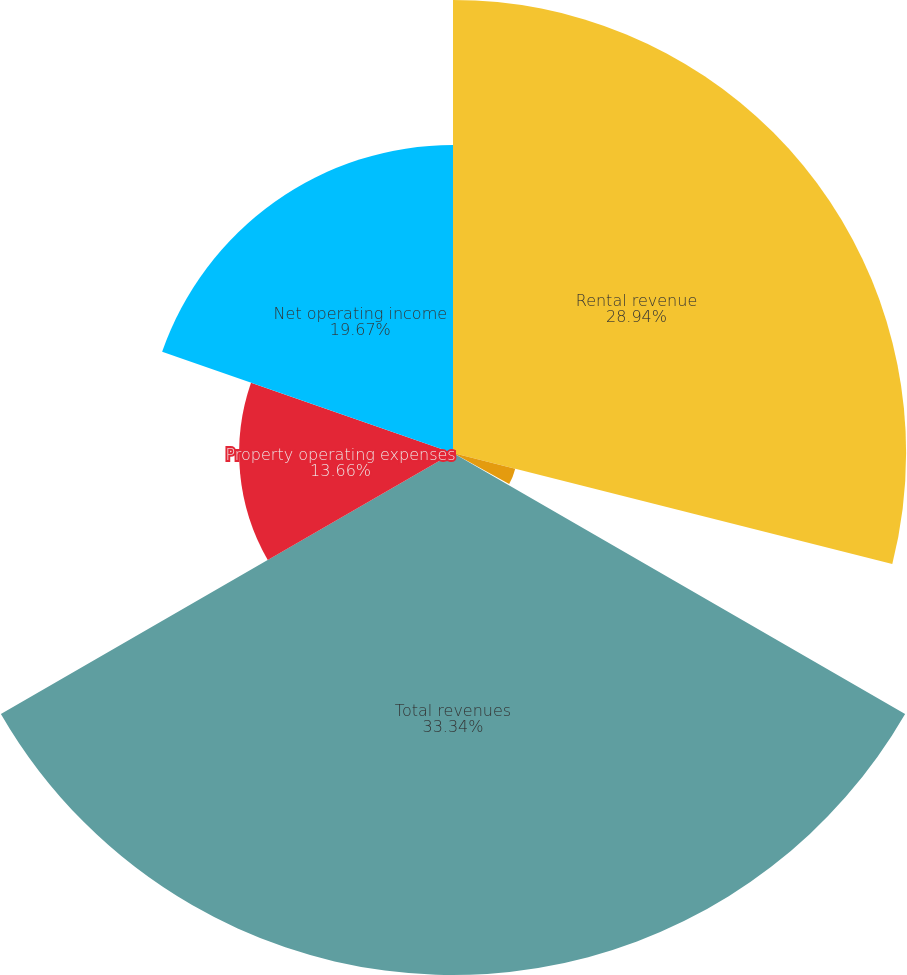Convert chart to OTSL. <chart><loc_0><loc_0><loc_500><loc_500><pie_chart><fcel>Rental revenue<fcel>Escalation and reimbursement<fcel>Other income<fcel>Total revenues<fcel>Property operating expenses<fcel>Net operating income<nl><fcel>28.94%<fcel>4.1%<fcel>0.29%<fcel>33.34%<fcel>13.66%<fcel>19.67%<nl></chart> 